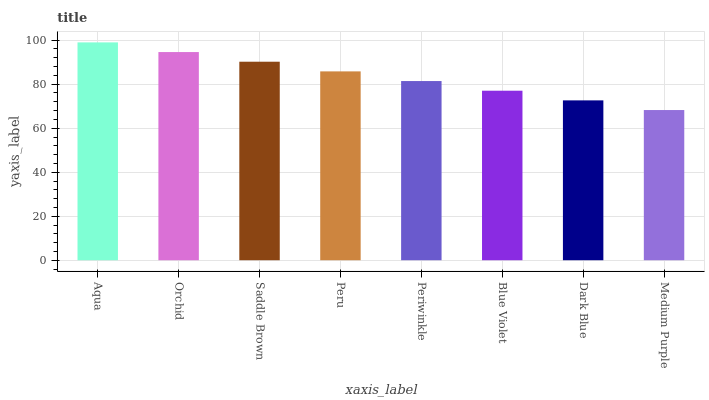Is Medium Purple the minimum?
Answer yes or no. Yes. Is Aqua the maximum?
Answer yes or no. Yes. Is Orchid the minimum?
Answer yes or no. No. Is Orchid the maximum?
Answer yes or no. No. Is Aqua greater than Orchid?
Answer yes or no. Yes. Is Orchid less than Aqua?
Answer yes or no. Yes. Is Orchid greater than Aqua?
Answer yes or no. No. Is Aqua less than Orchid?
Answer yes or no. No. Is Peru the high median?
Answer yes or no. Yes. Is Periwinkle the low median?
Answer yes or no. Yes. Is Periwinkle the high median?
Answer yes or no. No. Is Peru the low median?
Answer yes or no. No. 